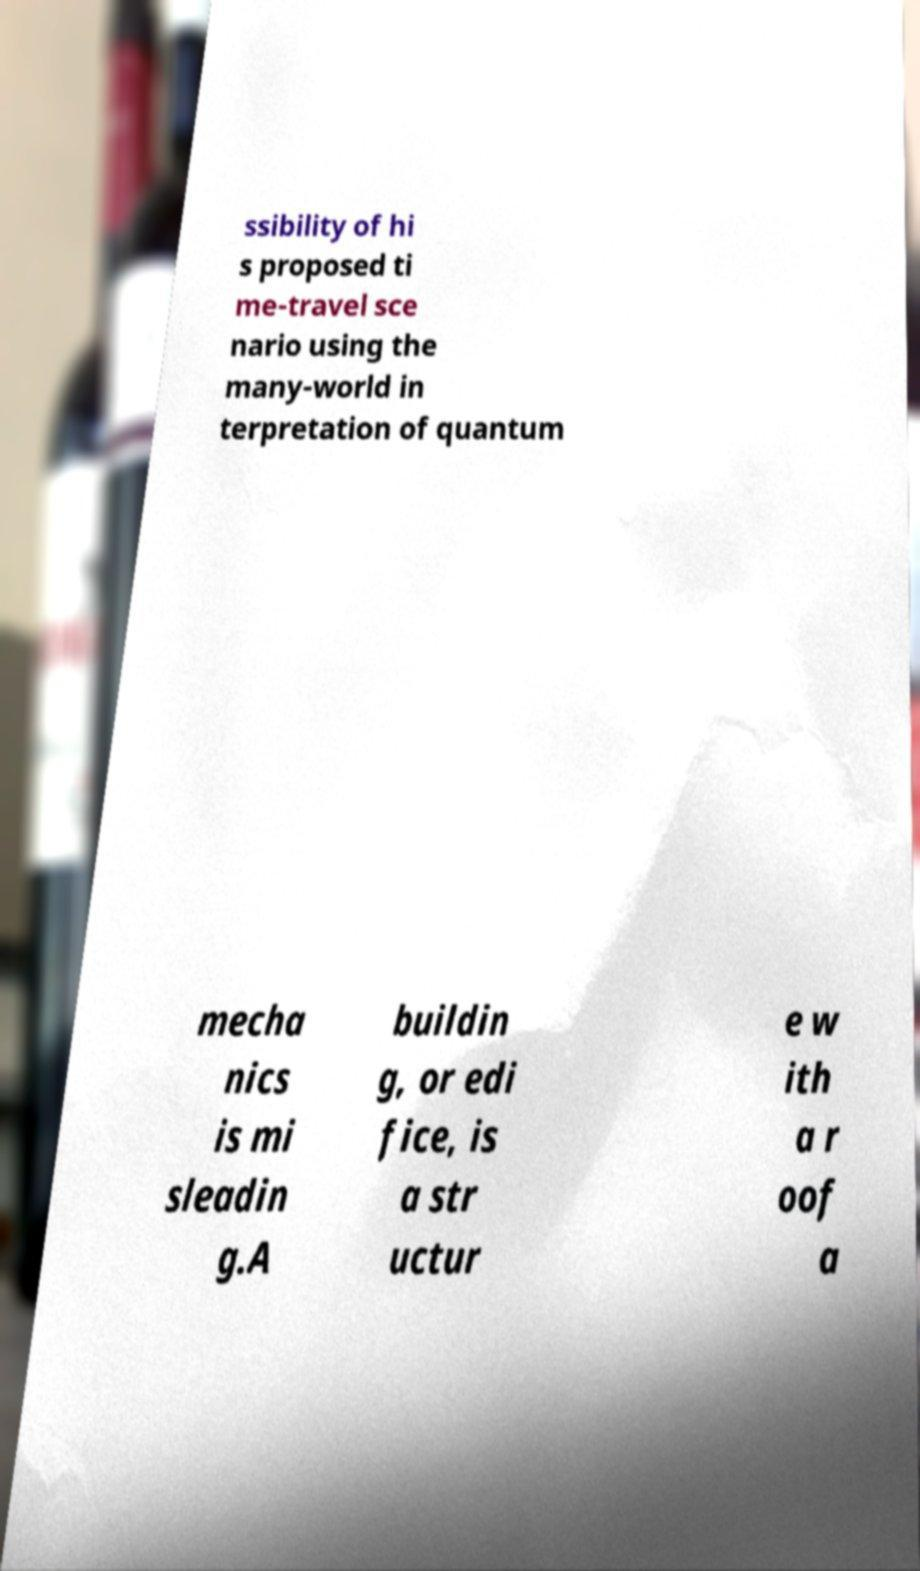Can you read and provide the text displayed in the image?This photo seems to have some interesting text. Can you extract and type it out for me? ssibility of hi s proposed ti me-travel sce nario using the many-world in terpretation of quantum mecha nics is mi sleadin g.A buildin g, or edi fice, is a str uctur e w ith a r oof a 